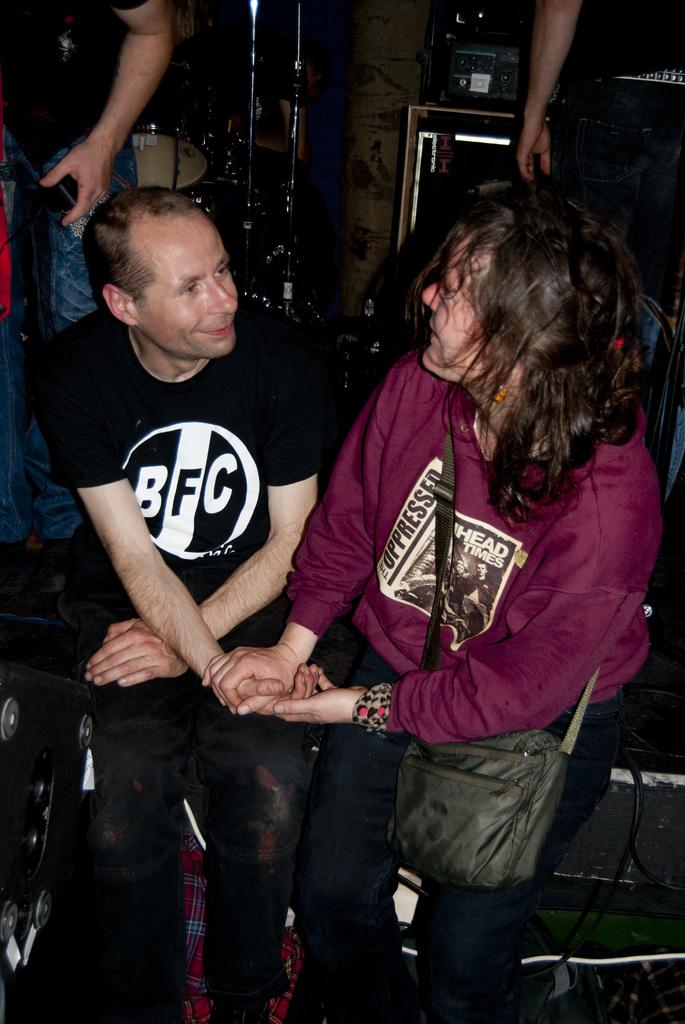<image>
Summarize the visual content of the image. A young woman holds hands with a man in a black BFC t-shirt. 